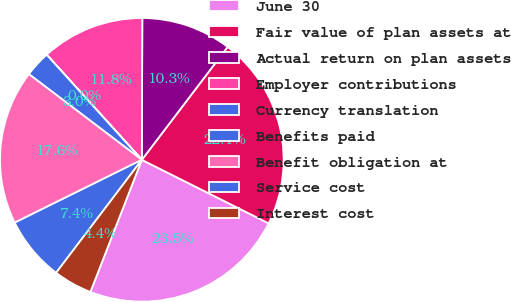Convert chart. <chart><loc_0><loc_0><loc_500><loc_500><pie_chart><fcel>June 30<fcel>Fair value of plan assets at<fcel>Actual return on plan assets<fcel>Employer contributions<fcel>Currency translation<fcel>Benefits paid<fcel>Benefit obligation at<fcel>Service cost<fcel>Interest cost<nl><fcel>23.52%<fcel>22.05%<fcel>10.29%<fcel>11.76%<fcel>0.01%<fcel>2.95%<fcel>17.64%<fcel>7.36%<fcel>4.42%<nl></chart> 